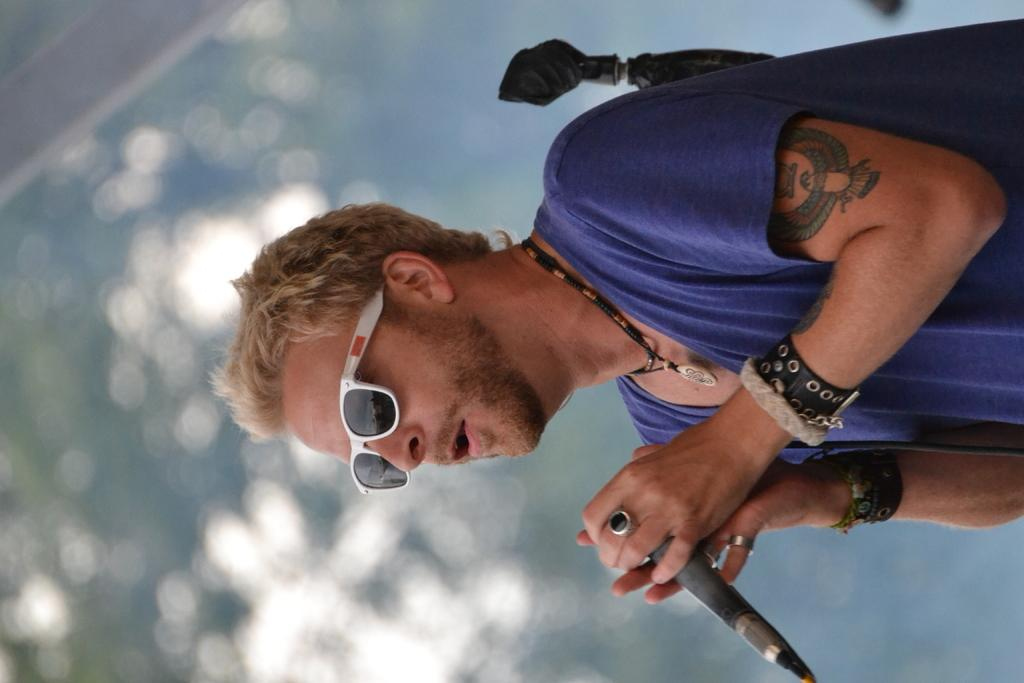What is the main subject of the image? The main subject of the image is a man. What is the man holding in the image? The man is holding a microphone. What type of protective eyewear is the man wearing? The man is wearing goggles. Can you describe the background of the image? The background of the image is blurred. What type of cracker is the man eating in the image? There is no cracker present in the image; the man is holding a microphone and wearing goggles. What is the man's profession, and how does it relate to love? There is no information about the man's profession or any connection to love in the image. 